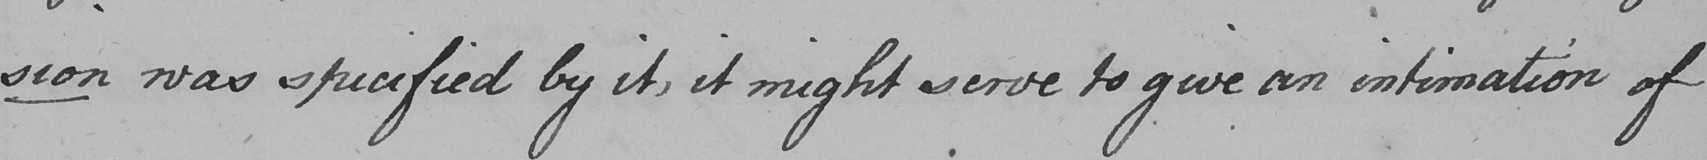What does this handwritten line say? sion was specified by it , it might serve to give an intimation of 